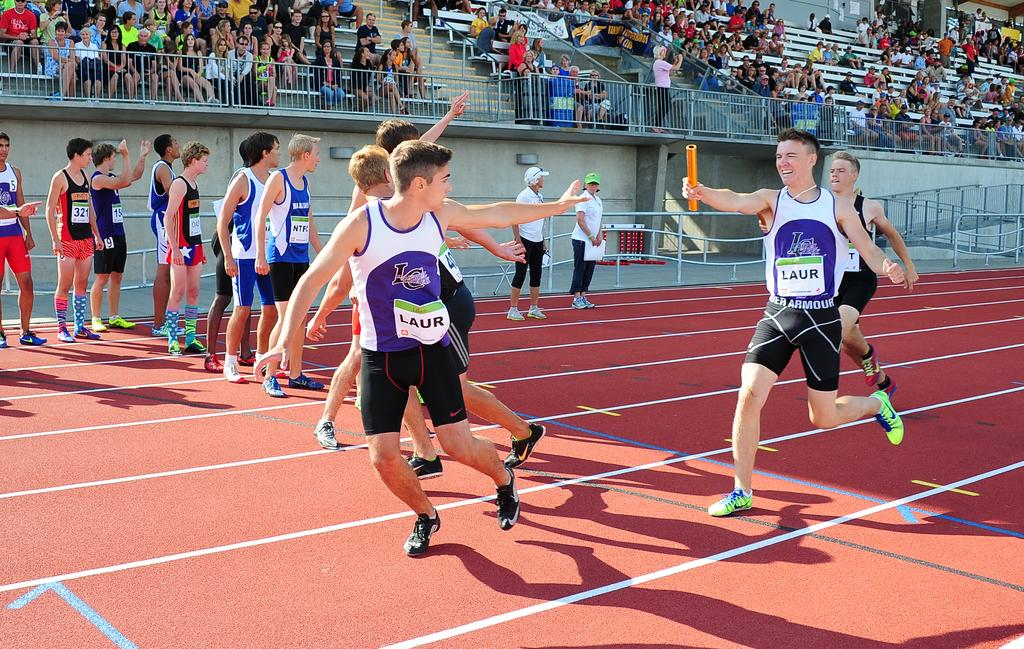<image>
Give a short and clear explanation of the subsequent image. A boy in Under Armour shorts handing a baton to another boy in a relay race. 